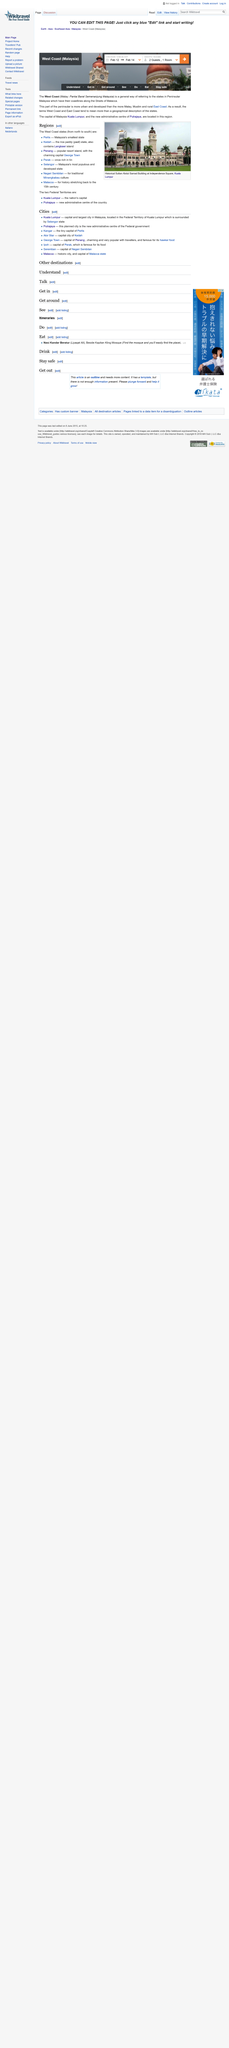List a handful of essential elements in this visual. Perlis is the smallest state in Malaysia. Kuala Lumpur and Putrajaya are the two Federal Territories of Malaysia. Selangor is the most populous and developed state in Malaysia, making it the country's premier destination for business, leisure, and entertainment. 